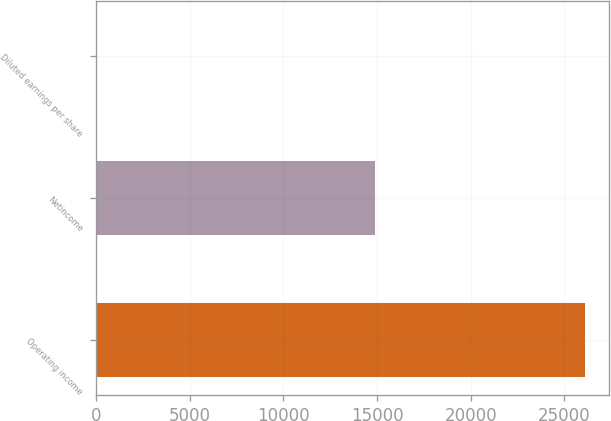<chart> <loc_0><loc_0><loc_500><loc_500><bar_chart><fcel>Operating income<fcel>Netincome<fcel>Diluted earnings per share<nl><fcel>26103<fcel>14872<fcel>0.38<nl></chart> 